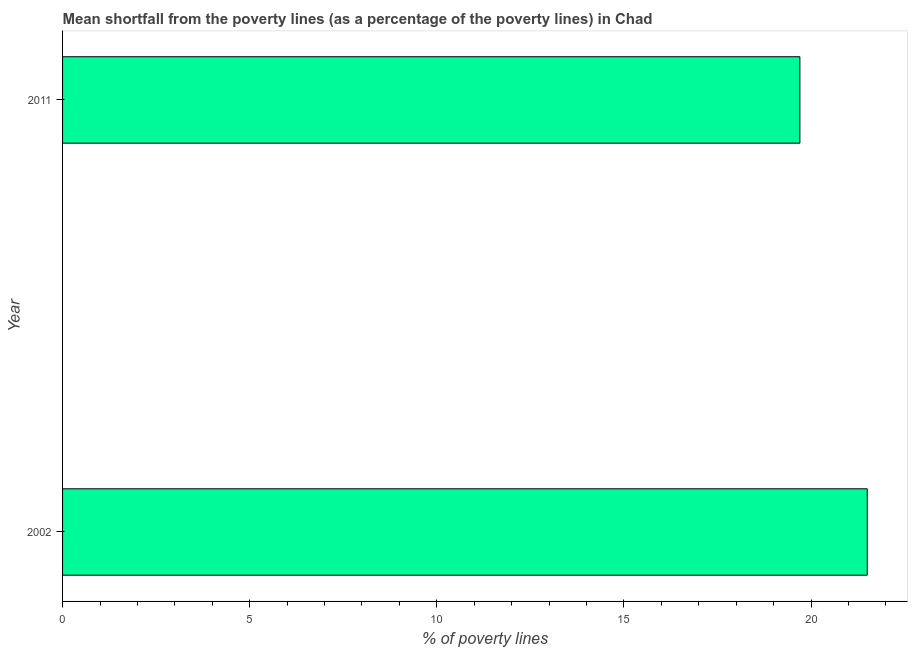What is the title of the graph?
Your answer should be very brief. Mean shortfall from the poverty lines (as a percentage of the poverty lines) in Chad. What is the label or title of the X-axis?
Provide a succinct answer. % of poverty lines. What is the label or title of the Y-axis?
Provide a succinct answer. Year. What is the poverty gap at national poverty lines in 2011?
Your answer should be very brief. 19.7. Across all years, what is the maximum poverty gap at national poverty lines?
Offer a very short reply. 21.5. In which year was the poverty gap at national poverty lines minimum?
Make the answer very short. 2011. What is the sum of the poverty gap at national poverty lines?
Ensure brevity in your answer.  41.2. What is the difference between the poverty gap at national poverty lines in 2002 and 2011?
Your answer should be compact. 1.8. What is the average poverty gap at national poverty lines per year?
Make the answer very short. 20.6. What is the median poverty gap at national poverty lines?
Make the answer very short. 20.6. In how many years, is the poverty gap at national poverty lines greater than 13 %?
Offer a very short reply. 2. What is the ratio of the poverty gap at national poverty lines in 2002 to that in 2011?
Provide a succinct answer. 1.09. Is the poverty gap at national poverty lines in 2002 less than that in 2011?
Ensure brevity in your answer.  No. How many years are there in the graph?
Your answer should be compact. 2. What is the difference between two consecutive major ticks on the X-axis?
Ensure brevity in your answer.  5. What is the % of poverty lines of 2002?
Your answer should be very brief. 21.5. What is the % of poverty lines of 2011?
Give a very brief answer. 19.7. What is the difference between the % of poverty lines in 2002 and 2011?
Offer a terse response. 1.8. What is the ratio of the % of poverty lines in 2002 to that in 2011?
Your response must be concise. 1.09. 